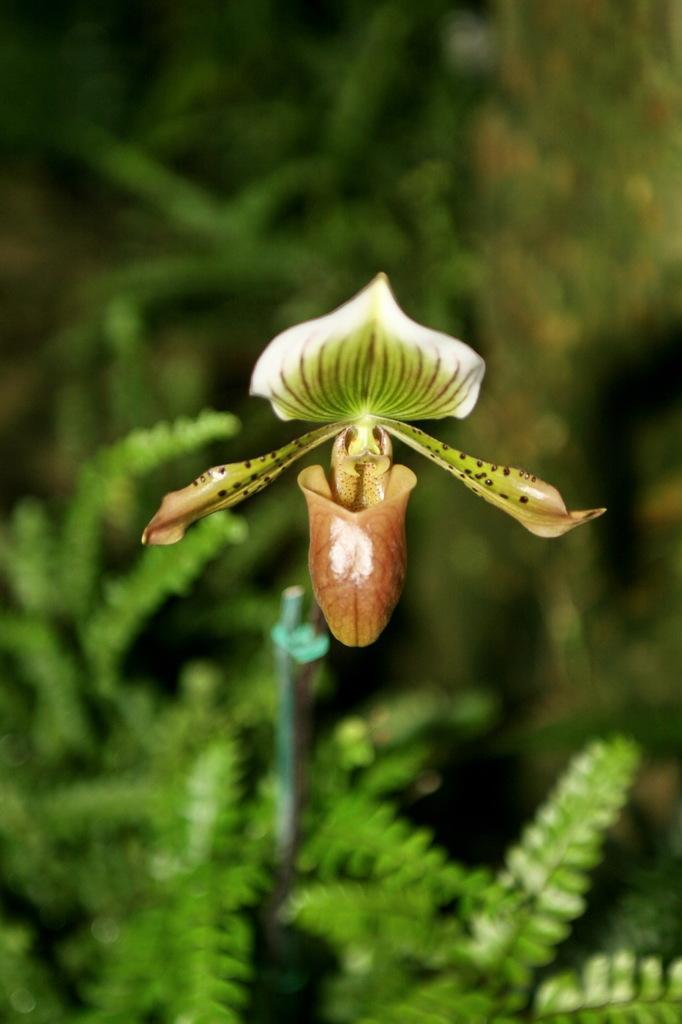In one or two sentences, can you explain what this image depicts? In the center of the picture there is a flower. In the background there is greenery. 